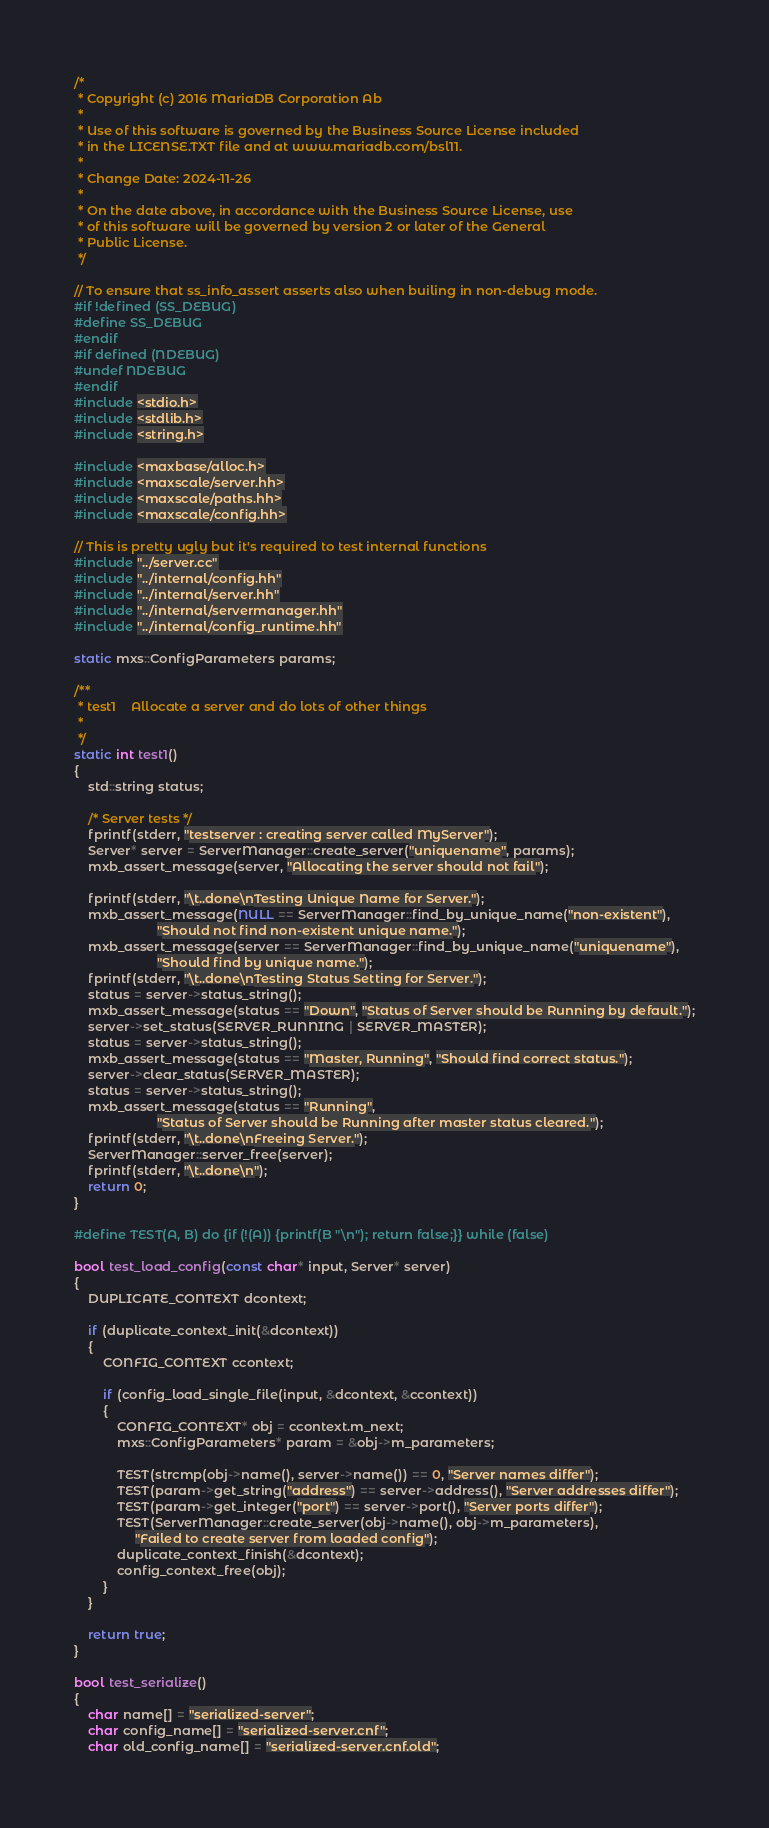<code> <loc_0><loc_0><loc_500><loc_500><_C++_>/*
 * Copyright (c) 2016 MariaDB Corporation Ab
 *
 * Use of this software is governed by the Business Source License included
 * in the LICENSE.TXT file and at www.mariadb.com/bsl11.
 *
 * Change Date: 2024-11-26
 *
 * On the date above, in accordance with the Business Source License, use
 * of this software will be governed by version 2 or later of the General
 * Public License.
 */

// To ensure that ss_info_assert asserts also when builing in non-debug mode.
#if !defined (SS_DEBUG)
#define SS_DEBUG
#endif
#if defined (NDEBUG)
#undef NDEBUG
#endif
#include <stdio.h>
#include <stdlib.h>
#include <string.h>

#include <maxbase/alloc.h>
#include <maxscale/server.hh>
#include <maxscale/paths.hh>
#include <maxscale/config.hh>

// This is pretty ugly but it's required to test internal functions
#include "../server.cc"
#include "../internal/config.hh"
#include "../internal/server.hh"
#include "../internal/servermanager.hh"
#include "../internal/config_runtime.hh"

static mxs::ConfigParameters params;

/**
 * test1    Allocate a server and do lots of other things
 *
 */
static int test1()
{
    std::string status;

    /* Server tests */
    fprintf(stderr, "testserver : creating server called MyServer");
    Server* server = ServerManager::create_server("uniquename", params);
    mxb_assert_message(server, "Allocating the server should not fail");

    fprintf(stderr, "\t..done\nTesting Unique Name for Server.");
    mxb_assert_message(NULL == ServerManager::find_by_unique_name("non-existent"),
                       "Should not find non-existent unique name.");
    mxb_assert_message(server == ServerManager::find_by_unique_name("uniquename"),
                       "Should find by unique name.");
    fprintf(stderr, "\t..done\nTesting Status Setting for Server.");
    status = server->status_string();
    mxb_assert_message(status == "Down", "Status of Server should be Running by default.");
    server->set_status(SERVER_RUNNING | SERVER_MASTER);
    status = server->status_string();
    mxb_assert_message(status == "Master, Running", "Should find correct status.");
    server->clear_status(SERVER_MASTER);
    status = server->status_string();
    mxb_assert_message(status == "Running",
                       "Status of Server should be Running after master status cleared.");
    fprintf(stderr, "\t..done\nFreeing Server.");
    ServerManager::server_free(server);
    fprintf(stderr, "\t..done\n");
    return 0;
}

#define TEST(A, B) do {if (!(A)) {printf(B "\n"); return false;}} while (false)

bool test_load_config(const char* input, Server* server)
{
    DUPLICATE_CONTEXT dcontext;

    if (duplicate_context_init(&dcontext))
    {
        CONFIG_CONTEXT ccontext;

        if (config_load_single_file(input, &dcontext, &ccontext))
        {
            CONFIG_CONTEXT* obj = ccontext.m_next;
            mxs::ConfigParameters* param = &obj->m_parameters;

            TEST(strcmp(obj->name(), server->name()) == 0, "Server names differ");
            TEST(param->get_string("address") == server->address(), "Server addresses differ");
            TEST(param->get_integer("port") == server->port(), "Server ports differ");
            TEST(ServerManager::create_server(obj->name(), obj->m_parameters),
                 "Failed to create server from loaded config");
            duplicate_context_finish(&dcontext);
            config_context_free(obj);
        }
    }

    return true;
}

bool test_serialize()
{
    char name[] = "serialized-server";
    char config_name[] = "serialized-server.cnf";
    char old_config_name[] = "serialized-server.cnf.old";</code> 